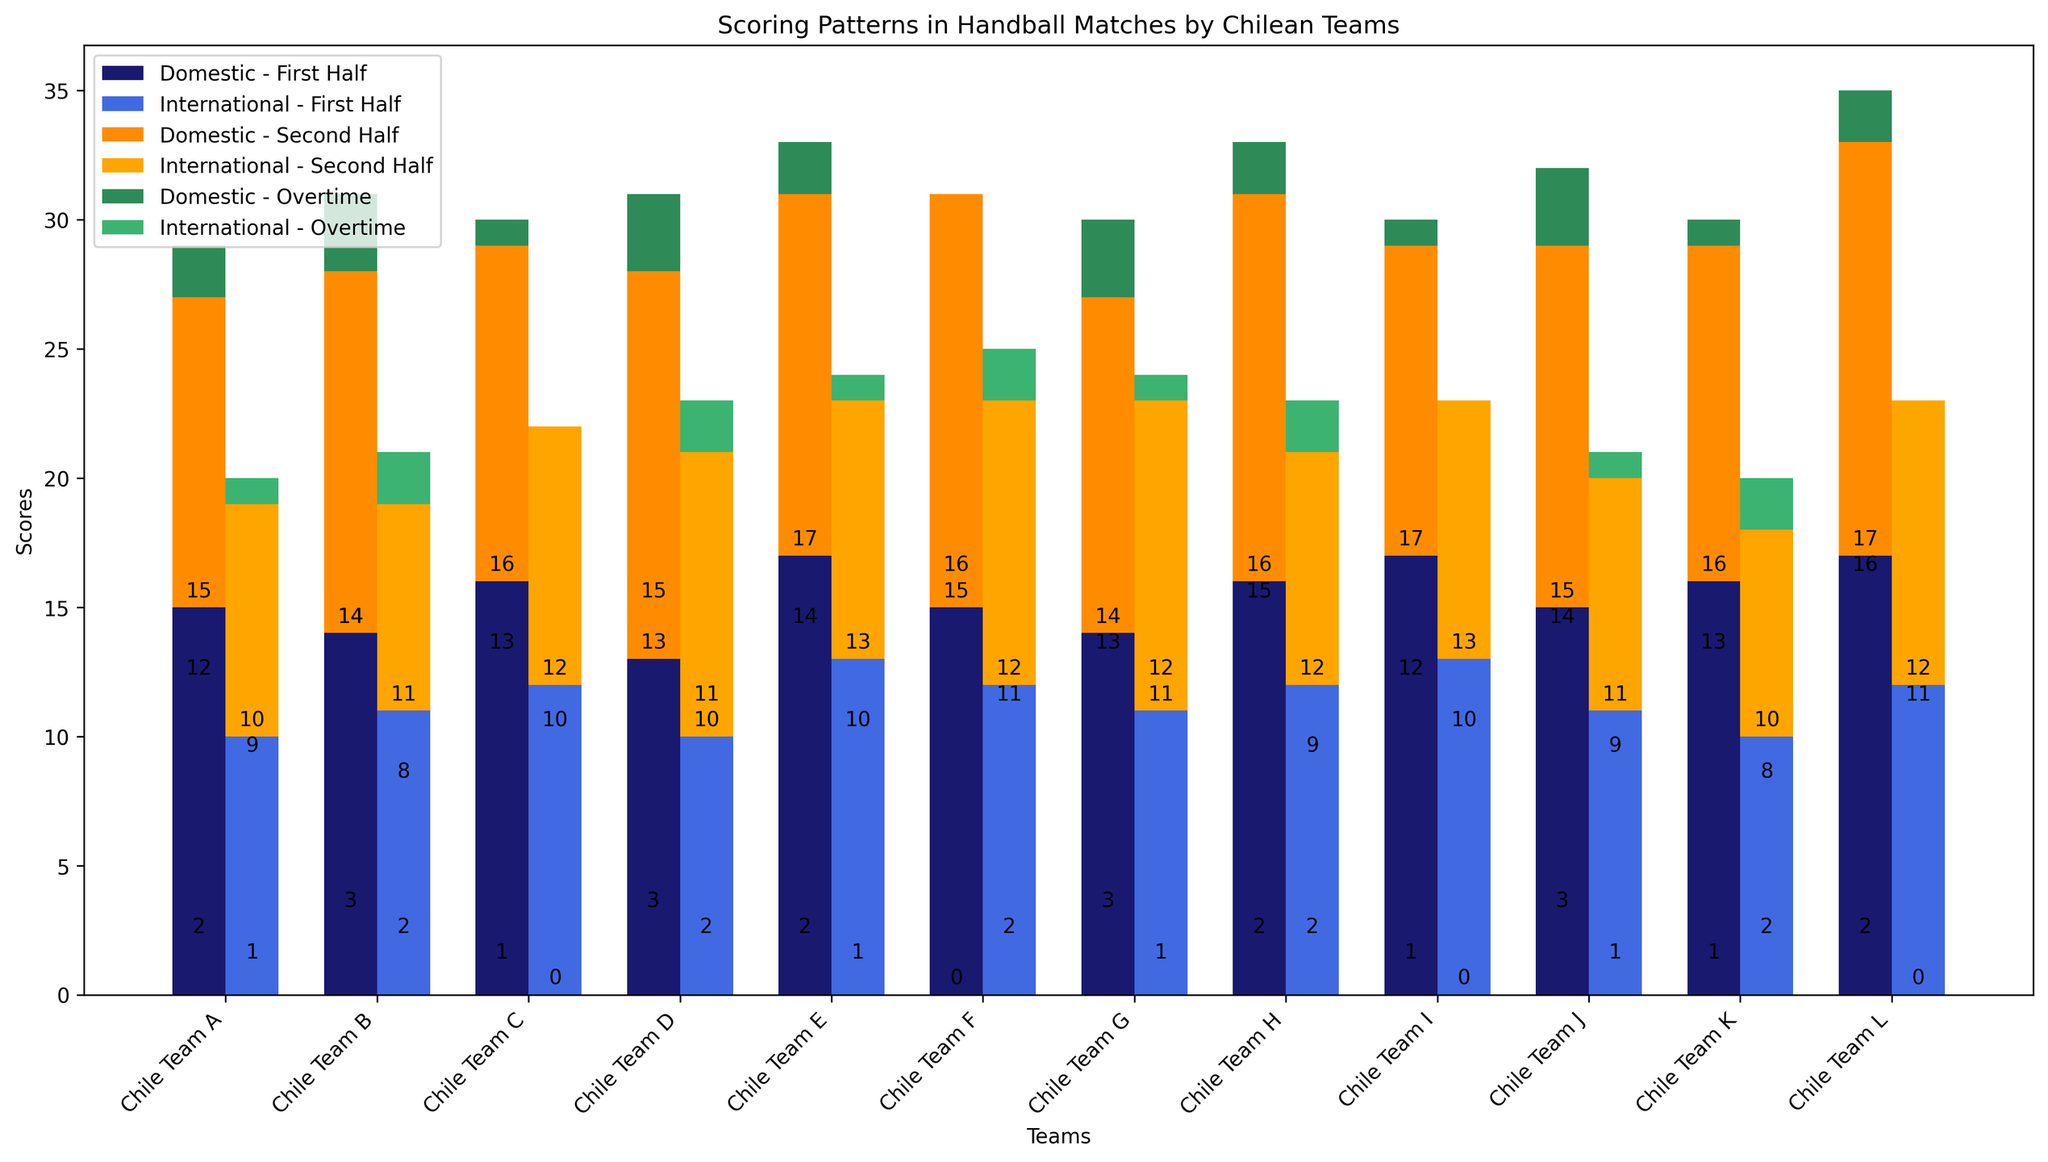Which team scored the most in Domestic competitions during the First Half? Look at the bars representing "Domestic - First Half" in midnight blue; find the tallest bar. Chile Team E, with 17 points, has the tallest bar.
Answer: Chile Team E How does the total score of Chile Team A compare between Domestic and International competitions? Sum the scores of Chile Team A for each competition. Domestic: 15 (First Half) + 12 (Second Half) + 2 (Overtime) = 29. International: 10 (First Half) + 9 (Second Half) + 1 (Overtime) = 20. Chile Team A scored more in Domestic competitions.
Answer: Domestic: 29, International: 20 Which competition shows a higher average overtime score, Domestic or International? Calculate the average overtime scores. Domestic: (2+3+1+3+2+0+3+2+1+3+1+2)/12 = 1.67; International: (1+2+0+2+1+2+1+2+0+1+2+0)/12 = 1.08; Domestic has a higher average overtime score.
Answer: Domestic: 1.67, International: 1.08 Which team shows the smallest difference in their First and Second Half scores in International competitions? Subtract the First Half score from the Second Half score for each team in International competitions and find the smallest difference. Chile Team D has Second Half: 11, First Half: 10, difference = 1.
Answer: Chile Team D What colors represent the Domestic and International competitions' Second Half scores? Refer to the visual attributes on the plot where these scores are indicated. Domestic - Second Half is in dark orange, International - Second Half is in orange.
Answer: Domestic: dark orange, International: orange Which team has the highest aggregate score combining all periods across both competitions? Sum the scores of both Domestic and International competitions for each team and find the highest total. Chile Team L's total score is Domestic (17+16+2) + International (12+11+0) = 58.
Answer: Chile Team L Between Chile Team F and Chile Team H, which team has a higher Domestic overtime score? Compare the Domestic overtime scores for both teams. Chile Team F: 0, Chile Team H: 2. Chile Team H has a higher score.
Answer: Chile Team H How does Chile Team C's Domestic First Half score compare to its International First Half score? Compare the scores directly. Domestic First Half: 16, International First Half: 12. Chile Team C scored higher in Domestic.
Answer: Domestic: 16, International: 12 What is the difference between the Domestic and International Second Half scores for Chile Team G? Subtract the International score from the Domestic score for the Second Half. Domestic: 13, International: 12; Difference = 13 - 12 = 1.
Answer: 1 Which team's International First Half score is visually represented by the shortest bar? Look for the shortest bar among all "International - First Half" bars in royal blue. Chile Team K has the shortest bar with 10 points.
Answer: Chile Team K 